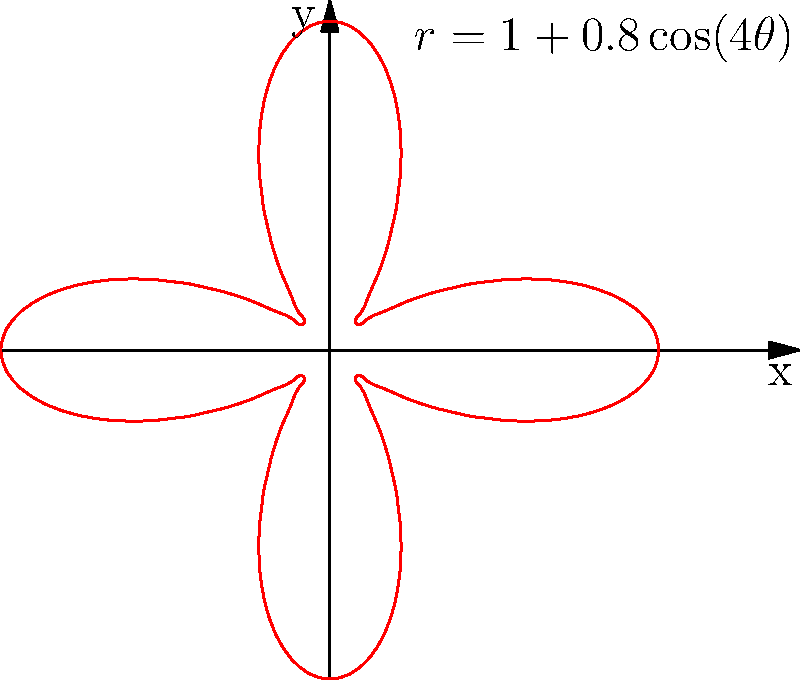Plácido Domingo's resonant tenor voice is known for its exceptional projection in opera houses. If his voice's radiation pattern is represented by the polar equation $r = 1 + 0.8\cos(4\theta)$, what is the maximum distance his voice projects, and in how many primary directions does it reach this maximum? To solve this problem, we need to follow these steps:

1) The maximum distance of projection occurs at the maximum value of $r$ in the given equation:
   $r = 1 + 0.8\cos(4\theta)$

2) The cosine function oscillates between -1 and 1. The maximum value of $r$ will occur when $\cos(4\theta) = 1$.

3) When $\cos(4\theta) = 1$, the equation becomes:
   $r_{max} = 1 + 0.8(1) = 1.8$

4) To find how many times this maximum occurs, we need to solve:
   $\cos(4\theta) = 1$

5) This occurs when $4\theta = 0°, 360°, 720°, ...$ or any multiple of $360°$.

6) In the range $0 \leq \theta < 360°$, this happens when:
   $\theta = 0°, 90°, 180°, 270°$

Therefore, Domingo's voice reaches its maximum projection of 1.8 units in 4 primary directions.
Answer: 1.8 units; 4 directions 